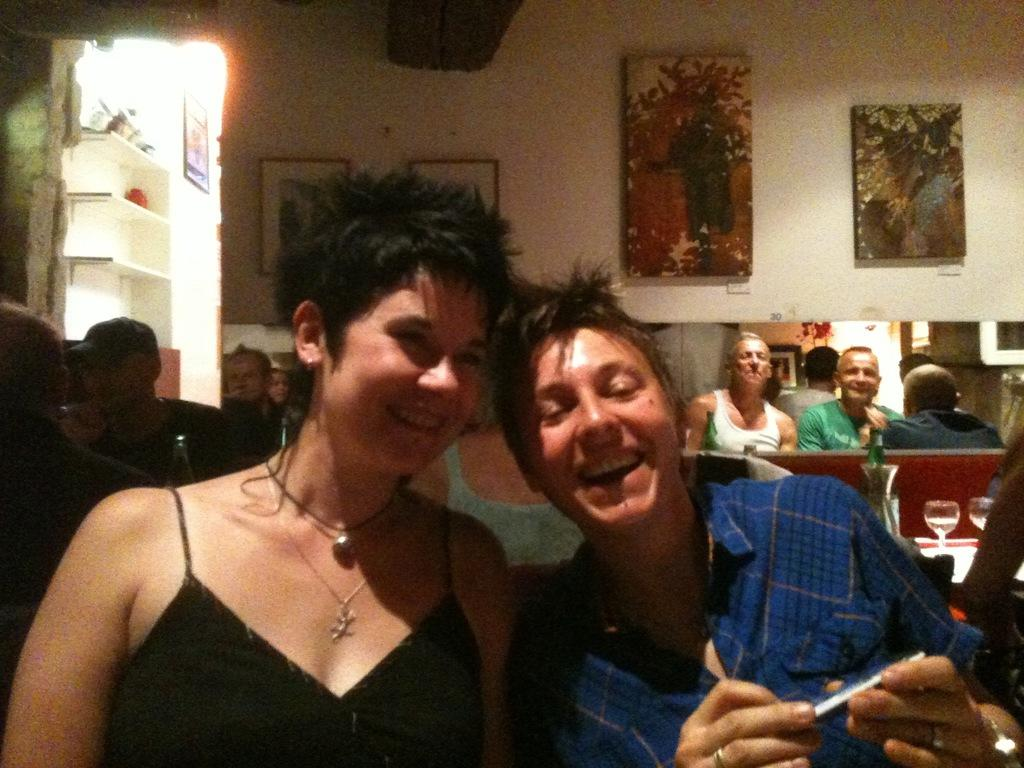How many people are in the main focus of the image? There are two persons in the center of the image. What are the expressions on the faces of the two main persons? The two persons are smiling. Can you describe the background of the image? There are other persons in the background of the image, and there are frames placed on the wall. What is the condition of the boundary between the two main persons in the image? There is no boundary between the two main persons in the image; they are standing close to each other and smiling. 